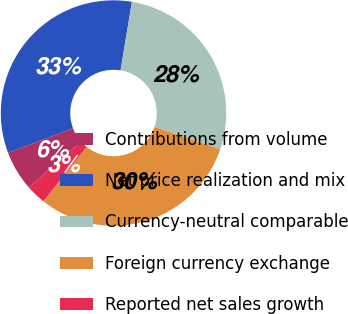Convert chart. <chart><loc_0><loc_0><loc_500><loc_500><pie_chart><fcel>Contributions from volume<fcel>Net price realization and mix<fcel>Currency-neutral comparable<fcel>Foreign currency exchange<fcel>Reported net sales growth<nl><fcel>5.73%<fcel>33.35%<fcel>27.59%<fcel>30.47%<fcel>2.85%<nl></chart> 